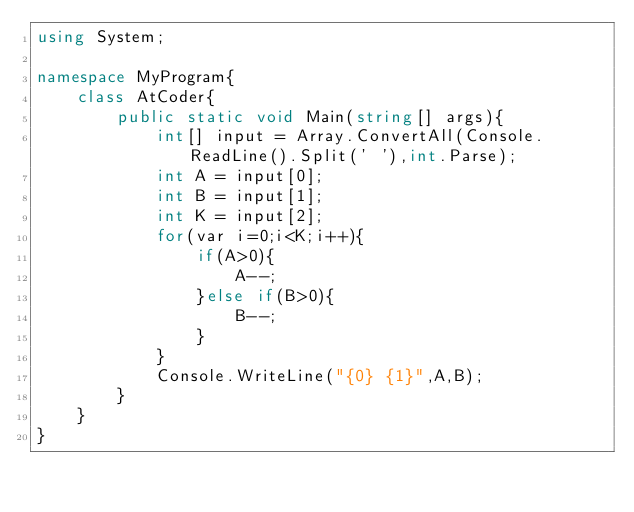<code> <loc_0><loc_0><loc_500><loc_500><_C#_>using System;

namespace MyProgram{
    class AtCoder{
        public static void Main(string[] args){
            int[] input = Array.ConvertAll(Console.ReadLine().Split(' '),int.Parse);
            int A = input[0];
            int B = input[1];
            int K = input[2];
            for(var i=0;i<K;i++){
                if(A>0){
                    A--;
                }else if(B>0){
                    B--;
                }
            }
            Console.WriteLine("{0} {1}",A,B);
        }
    }
}</code> 